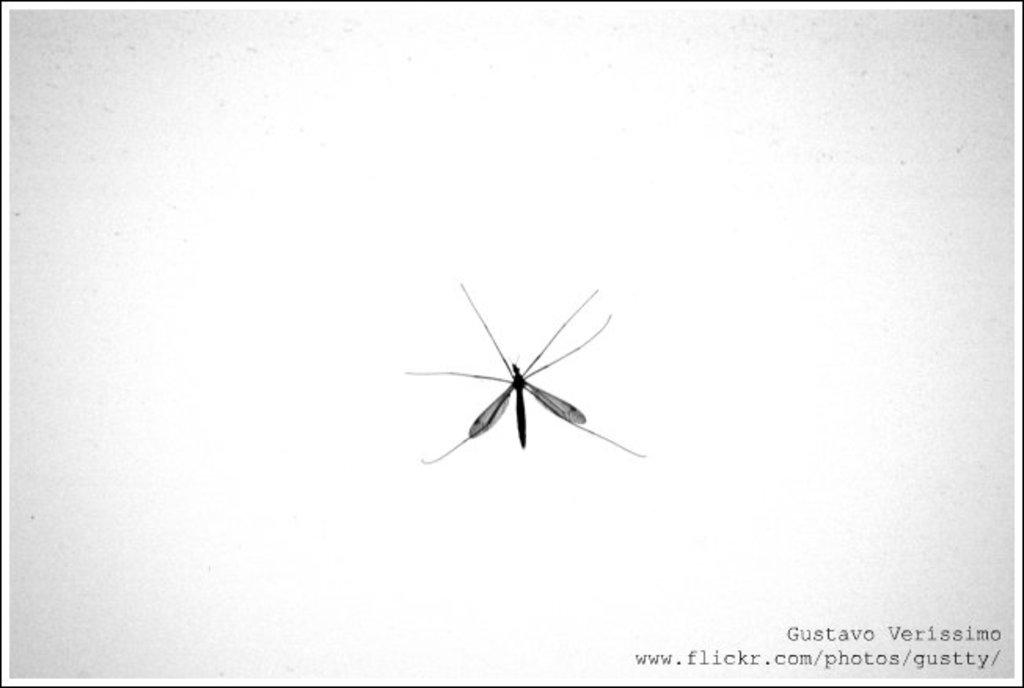What is the main subject of the image? There is a mosquito in the image. Where is the mosquito located? The mosquito is on the wall. What is the color scheme of the image? The image is black and white. What type of shape is the boy drawing during the meeting in the image? There is no boy or meeting present in the image, and therefore no such activity can be observed. 